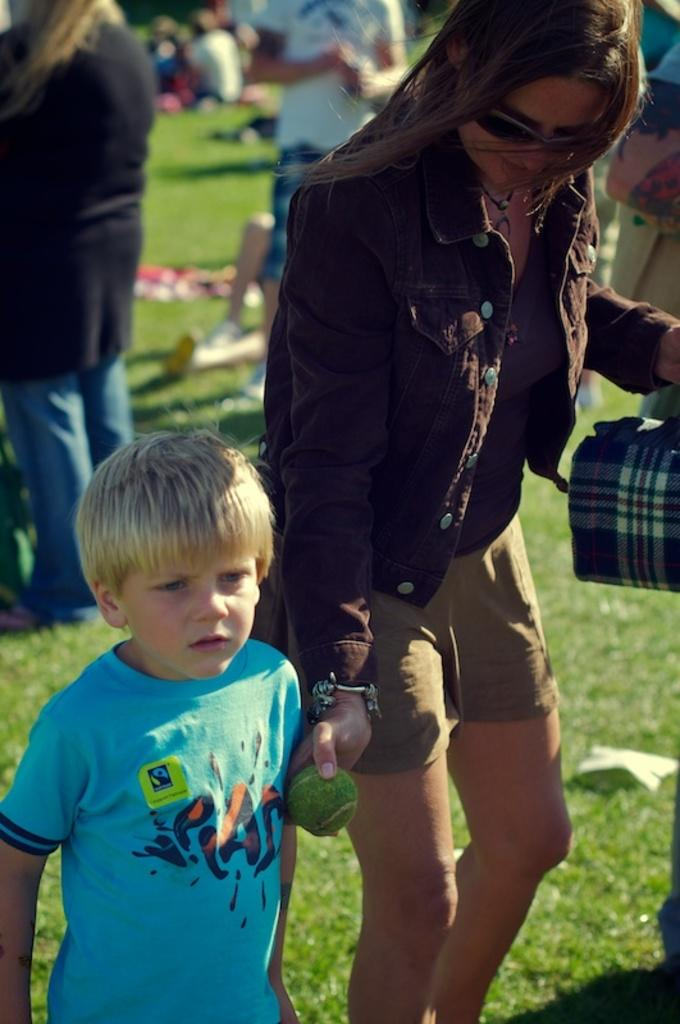Who is present in the image? There is a woman and a child in the image. What is the woman holding in the image? The woman is holding a bag and a ball in the image. What type of surface is visible in the image? There is grass visible in the image. How many people are in the image? There is a group of people in the image. What is on the ground in the image? There are objects on the ground in the image. What letter does the caption on the ball say in the image? There is no caption on the ball in the image, and therefore, no letter can be read. What type of spark can be seen coming from the woman's hand in the image? There is no spark present in the image; the woman is holding a ball and a bag. 